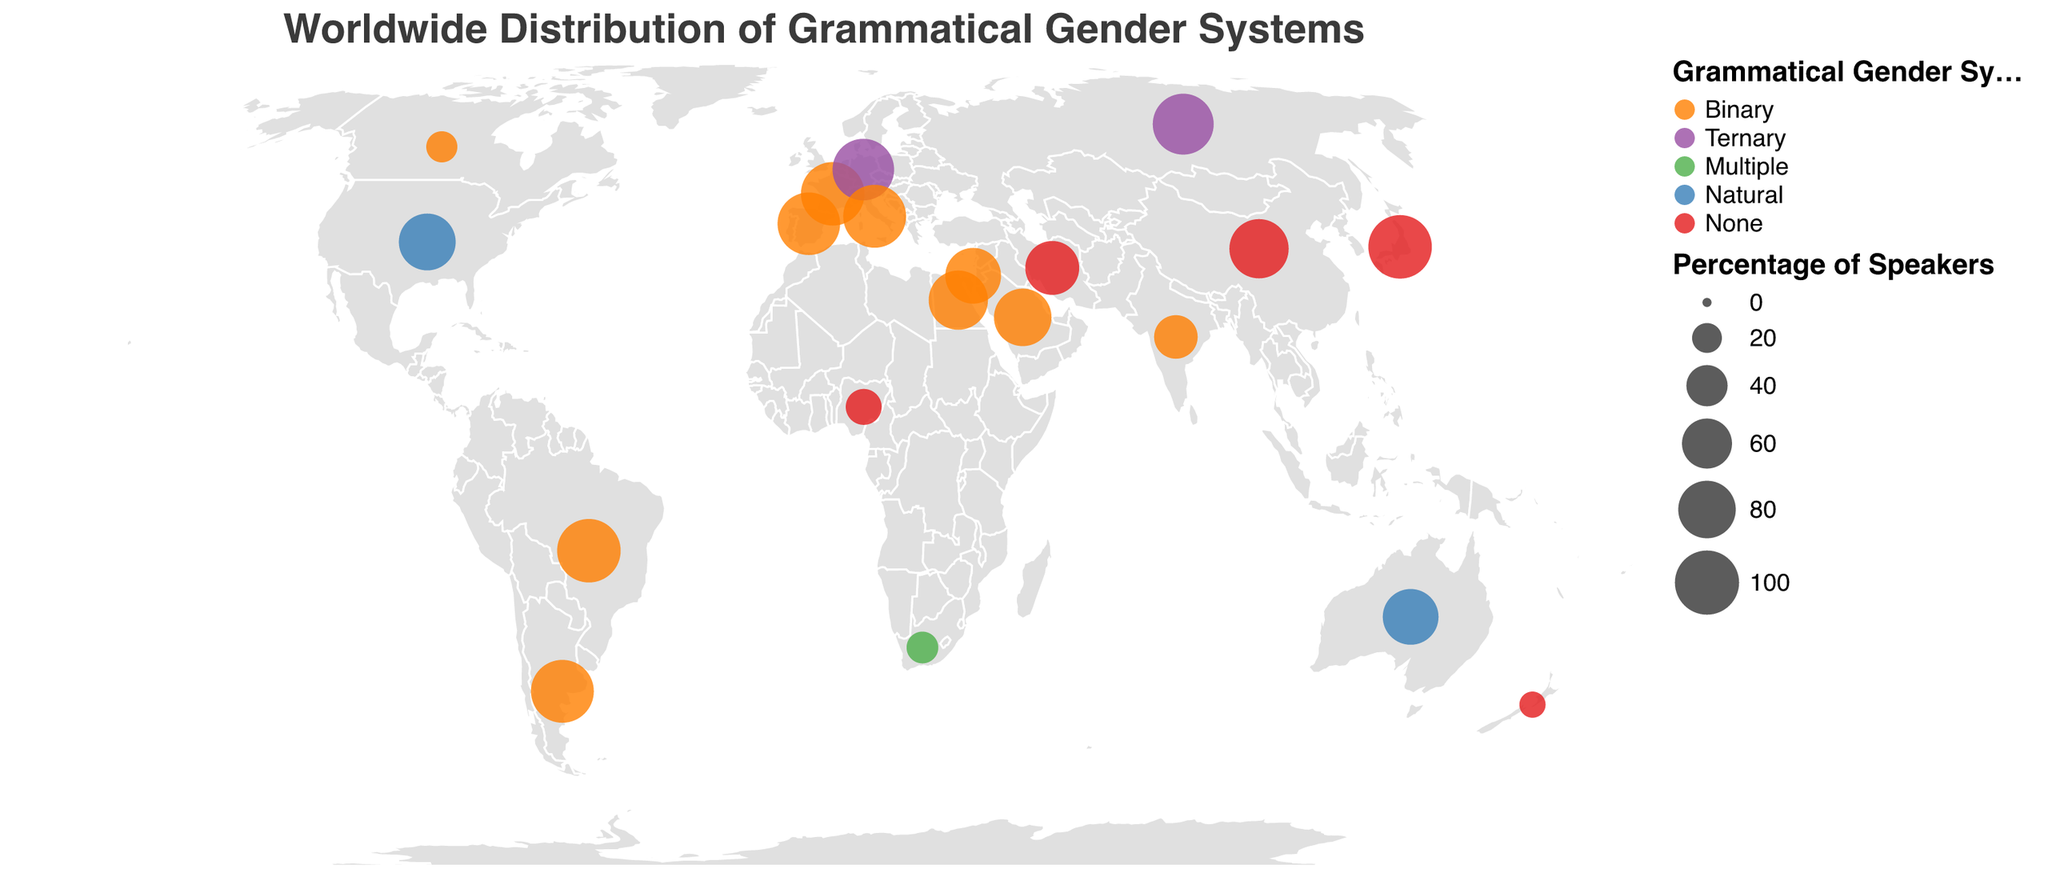What's the most common grammatical gender system globally based on the figure? The figure uses colors to represent different grammatical gender systems. The most prevalent color will indicate the most common system. Observe that "Binary" (orange color) appears more frequently than other colors.
Answer: Binary Which country in Europe has a ternary grammatical gender system? Look at the countries in Europe and identify which one has a color corresponding to the "Ternary" gender system (purple).
Answer: Germany and Russia Among Middle Eastern countries displayed, which has the highest percentage of speakers using a language with a "None" gender system? Focus on the Middle Eastern region and compare the percentages of speakers using the "None" gender system, marked in red. Iran has 70%.
Answer: Iran What is the grammatical gender system of the language with the highest percentage of speakers in Asia? Observe the size of circles in Asia. Japanese has the largest circle with 98% of its speakers. Check its color which represents its grammatical gender system (None in red).
Answer: None Which regions have languages with a "Multiple" grammatical gender system, and how many such languages are there? Identify regions with green circles corresponding to "Multiple". Only South Africa, an African country, is represented, indicating one such language.
Answer: Africa, 1 Compare the percentage of French speakers with a binary grammatical gender system in Canada and France. Which country has a higher percentage? Look at the size of circles for Canada and France where French is spoken. France has 98% while Canada has 22%.
Answer: France What is the grammatical gender system used by languages in Oceania and what are their respective percentages of speakers? Identify the colors and sizes of circles in Oceania. English (Natural, blue) in Australia with 75%, and Maori (None, red) in New Zealand with 15%.
Answer: Natural (75%), None (15%) Is there any country in the Middle East with a "Ternary" grammatical gender system? Identify countries in the Middle East and look for the purple color corresponding to the "Ternary" gender system. None of the countries in the Middle East have this system.
Answer: No Which language has the second highest percentage of speakers with a "Natural" grammatical gender system? Identify languages with "Natural" gender system (blue). The United States English (78%) has the highest, and Australia English (75%) has the second highest.
Answer: English in Australia Calculate the difference in the percentage of speakers using languages with "Binary" grammatical gender systems between Spain and India. Identify the percentages for Spain (95%) and India (45%) and compute the difference: 95% - 45% = 50%.
Answer: 50% 